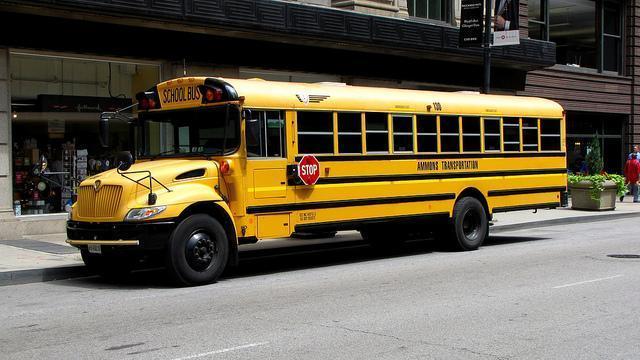Evaluate: Does the caption "The potted plant is at the back of the bus." match the image?
Answer yes or no. Yes. Is the statement "The bus is far away from the potted plant." accurate regarding the image?
Answer yes or no. No. 